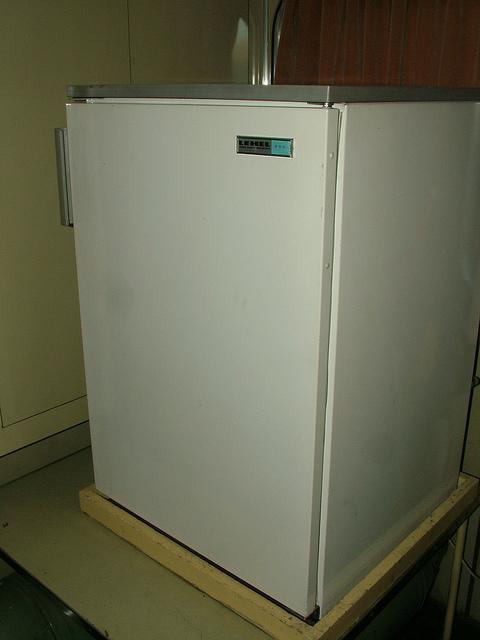Does this look like a freezer?
Write a very short answer. Yes. Is this a combination freezer/refrigerator?
Short answer required. No. Whose house is this?
Concise answer only. Unknown. How many doors are on this appliance?
Quick response, please. 1. What appliance is this?
Answer briefly. Freezer. What does the blue and black label say?
Short answer required. Frigidaire. How many doors is on this object?
Short answer required. 1. What is the top of this appliance made of?
Be succinct. Metal. 